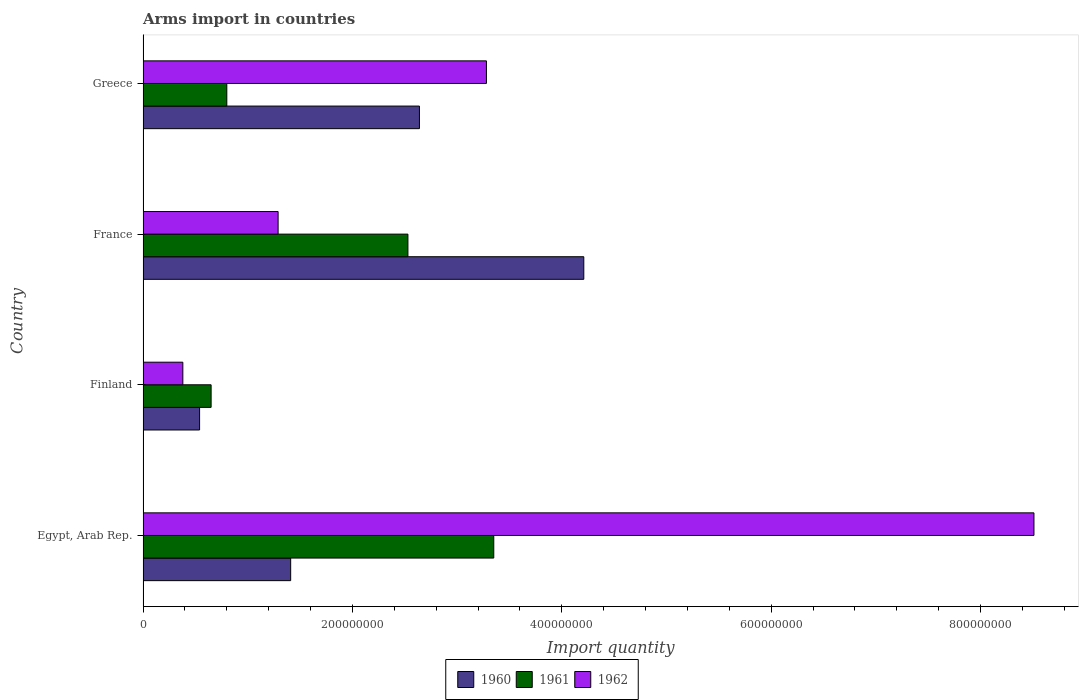How many different coloured bars are there?
Offer a very short reply. 3. How many groups of bars are there?
Provide a succinct answer. 4. Are the number of bars per tick equal to the number of legend labels?
Offer a very short reply. Yes. How many bars are there on the 2nd tick from the bottom?
Your answer should be very brief. 3. In how many cases, is the number of bars for a given country not equal to the number of legend labels?
Your answer should be very brief. 0. What is the total arms import in 1962 in Finland?
Your answer should be very brief. 3.80e+07. Across all countries, what is the maximum total arms import in 1961?
Offer a very short reply. 3.35e+08. Across all countries, what is the minimum total arms import in 1960?
Provide a succinct answer. 5.40e+07. In which country was the total arms import in 1960 maximum?
Provide a short and direct response. France. In which country was the total arms import in 1961 minimum?
Offer a very short reply. Finland. What is the total total arms import in 1962 in the graph?
Offer a terse response. 1.35e+09. What is the difference between the total arms import in 1961 in Egypt, Arab Rep. and that in France?
Keep it short and to the point. 8.20e+07. What is the difference between the total arms import in 1962 in Greece and the total arms import in 1961 in France?
Provide a succinct answer. 7.50e+07. What is the average total arms import in 1962 per country?
Provide a short and direct response. 3.36e+08. What is the difference between the total arms import in 1960 and total arms import in 1962 in Greece?
Offer a terse response. -6.40e+07. In how many countries, is the total arms import in 1962 greater than 520000000 ?
Give a very brief answer. 1. What is the ratio of the total arms import in 1962 in Egypt, Arab Rep. to that in Greece?
Your answer should be compact. 2.59. Is the total arms import in 1961 in Finland less than that in France?
Provide a succinct answer. Yes. Is the difference between the total arms import in 1960 in France and Greece greater than the difference between the total arms import in 1962 in France and Greece?
Ensure brevity in your answer.  Yes. What is the difference between the highest and the second highest total arms import in 1960?
Provide a short and direct response. 1.57e+08. What is the difference between the highest and the lowest total arms import in 1960?
Ensure brevity in your answer.  3.67e+08. What does the 2nd bar from the top in Greece represents?
Offer a terse response. 1961. Is it the case that in every country, the sum of the total arms import in 1962 and total arms import in 1960 is greater than the total arms import in 1961?
Your answer should be very brief. Yes. How many bars are there?
Your response must be concise. 12. Are all the bars in the graph horizontal?
Give a very brief answer. Yes. Does the graph contain any zero values?
Your answer should be very brief. No. Does the graph contain grids?
Make the answer very short. No. What is the title of the graph?
Your response must be concise. Arms import in countries. What is the label or title of the X-axis?
Make the answer very short. Import quantity. What is the label or title of the Y-axis?
Provide a short and direct response. Country. What is the Import quantity of 1960 in Egypt, Arab Rep.?
Provide a short and direct response. 1.41e+08. What is the Import quantity of 1961 in Egypt, Arab Rep.?
Provide a short and direct response. 3.35e+08. What is the Import quantity of 1962 in Egypt, Arab Rep.?
Your response must be concise. 8.51e+08. What is the Import quantity in 1960 in Finland?
Your response must be concise. 5.40e+07. What is the Import quantity in 1961 in Finland?
Offer a very short reply. 6.50e+07. What is the Import quantity of 1962 in Finland?
Keep it short and to the point. 3.80e+07. What is the Import quantity in 1960 in France?
Make the answer very short. 4.21e+08. What is the Import quantity of 1961 in France?
Give a very brief answer. 2.53e+08. What is the Import quantity of 1962 in France?
Provide a succinct answer. 1.29e+08. What is the Import quantity in 1960 in Greece?
Keep it short and to the point. 2.64e+08. What is the Import quantity of 1961 in Greece?
Make the answer very short. 8.00e+07. What is the Import quantity of 1962 in Greece?
Make the answer very short. 3.28e+08. Across all countries, what is the maximum Import quantity in 1960?
Provide a succinct answer. 4.21e+08. Across all countries, what is the maximum Import quantity of 1961?
Offer a terse response. 3.35e+08. Across all countries, what is the maximum Import quantity in 1962?
Make the answer very short. 8.51e+08. Across all countries, what is the minimum Import quantity in 1960?
Provide a succinct answer. 5.40e+07. Across all countries, what is the minimum Import quantity in 1961?
Keep it short and to the point. 6.50e+07. Across all countries, what is the minimum Import quantity in 1962?
Offer a terse response. 3.80e+07. What is the total Import quantity of 1960 in the graph?
Make the answer very short. 8.80e+08. What is the total Import quantity in 1961 in the graph?
Give a very brief answer. 7.33e+08. What is the total Import quantity in 1962 in the graph?
Offer a very short reply. 1.35e+09. What is the difference between the Import quantity of 1960 in Egypt, Arab Rep. and that in Finland?
Provide a short and direct response. 8.70e+07. What is the difference between the Import quantity in 1961 in Egypt, Arab Rep. and that in Finland?
Ensure brevity in your answer.  2.70e+08. What is the difference between the Import quantity of 1962 in Egypt, Arab Rep. and that in Finland?
Your answer should be compact. 8.13e+08. What is the difference between the Import quantity of 1960 in Egypt, Arab Rep. and that in France?
Your response must be concise. -2.80e+08. What is the difference between the Import quantity in 1961 in Egypt, Arab Rep. and that in France?
Ensure brevity in your answer.  8.20e+07. What is the difference between the Import quantity of 1962 in Egypt, Arab Rep. and that in France?
Your answer should be compact. 7.22e+08. What is the difference between the Import quantity in 1960 in Egypt, Arab Rep. and that in Greece?
Offer a terse response. -1.23e+08. What is the difference between the Import quantity of 1961 in Egypt, Arab Rep. and that in Greece?
Make the answer very short. 2.55e+08. What is the difference between the Import quantity of 1962 in Egypt, Arab Rep. and that in Greece?
Offer a terse response. 5.23e+08. What is the difference between the Import quantity of 1960 in Finland and that in France?
Make the answer very short. -3.67e+08. What is the difference between the Import quantity of 1961 in Finland and that in France?
Your response must be concise. -1.88e+08. What is the difference between the Import quantity in 1962 in Finland and that in France?
Your answer should be very brief. -9.10e+07. What is the difference between the Import quantity of 1960 in Finland and that in Greece?
Give a very brief answer. -2.10e+08. What is the difference between the Import quantity in 1961 in Finland and that in Greece?
Offer a terse response. -1.50e+07. What is the difference between the Import quantity of 1962 in Finland and that in Greece?
Keep it short and to the point. -2.90e+08. What is the difference between the Import quantity in 1960 in France and that in Greece?
Make the answer very short. 1.57e+08. What is the difference between the Import quantity in 1961 in France and that in Greece?
Give a very brief answer. 1.73e+08. What is the difference between the Import quantity in 1962 in France and that in Greece?
Offer a terse response. -1.99e+08. What is the difference between the Import quantity of 1960 in Egypt, Arab Rep. and the Import quantity of 1961 in Finland?
Give a very brief answer. 7.60e+07. What is the difference between the Import quantity of 1960 in Egypt, Arab Rep. and the Import quantity of 1962 in Finland?
Your response must be concise. 1.03e+08. What is the difference between the Import quantity of 1961 in Egypt, Arab Rep. and the Import quantity of 1962 in Finland?
Your answer should be very brief. 2.97e+08. What is the difference between the Import quantity in 1960 in Egypt, Arab Rep. and the Import quantity in 1961 in France?
Ensure brevity in your answer.  -1.12e+08. What is the difference between the Import quantity of 1961 in Egypt, Arab Rep. and the Import quantity of 1962 in France?
Your response must be concise. 2.06e+08. What is the difference between the Import quantity of 1960 in Egypt, Arab Rep. and the Import quantity of 1961 in Greece?
Ensure brevity in your answer.  6.10e+07. What is the difference between the Import quantity of 1960 in Egypt, Arab Rep. and the Import quantity of 1962 in Greece?
Offer a very short reply. -1.87e+08. What is the difference between the Import quantity of 1961 in Egypt, Arab Rep. and the Import quantity of 1962 in Greece?
Ensure brevity in your answer.  7.00e+06. What is the difference between the Import quantity of 1960 in Finland and the Import quantity of 1961 in France?
Your answer should be very brief. -1.99e+08. What is the difference between the Import quantity in 1960 in Finland and the Import quantity in 1962 in France?
Your answer should be compact. -7.50e+07. What is the difference between the Import quantity of 1961 in Finland and the Import quantity of 1962 in France?
Give a very brief answer. -6.40e+07. What is the difference between the Import quantity of 1960 in Finland and the Import quantity of 1961 in Greece?
Provide a short and direct response. -2.60e+07. What is the difference between the Import quantity in 1960 in Finland and the Import quantity in 1962 in Greece?
Your answer should be compact. -2.74e+08. What is the difference between the Import quantity of 1961 in Finland and the Import quantity of 1962 in Greece?
Your answer should be compact. -2.63e+08. What is the difference between the Import quantity of 1960 in France and the Import quantity of 1961 in Greece?
Keep it short and to the point. 3.41e+08. What is the difference between the Import quantity in 1960 in France and the Import quantity in 1962 in Greece?
Provide a succinct answer. 9.30e+07. What is the difference between the Import quantity in 1961 in France and the Import quantity in 1962 in Greece?
Provide a succinct answer. -7.50e+07. What is the average Import quantity in 1960 per country?
Keep it short and to the point. 2.20e+08. What is the average Import quantity of 1961 per country?
Give a very brief answer. 1.83e+08. What is the average Import quantity of 1962 per country?
Give a very brief answer. 3.36e+08. What is the difference between the Import quantity of 1960 and Import quantity of 1961 in Egypt, Arab Rep.?
Provide a succinct answer. -1.94e+08. What is the difference between the Import quantity in 1960 and Import quantity in 1962 in Egypt, Arab Rep.?
Provide a short and direct response. -7.10e+08. What is the difference between the Import quantity in 1961 and Import quantity in 1962 in Egypt, Arab Rep.?
Keep it short and to the point. -5.16e+08. What is the difference between the Import quantity of 1960 and Import quantity of 1961 in Finland?
Give a very brief answer. -1.10e+07. What is the difference between the Import quantity of 1960 and Import quantity of 1962 in Finland?
Keep it short and to the point. 1.60e+07. What is the difference between the Import quantity of 1961 and Import quantity of 1962 in Finland?
Make the answer very short. 2.70e+07. What is the difference between the Import quantity of 1960 and Import quantity of 1961 in France?
Provide a succinct answer. 1.68e+08. What is the difference between the Import quantity in 1960 and Import quantity in 1962 in France?
Offer a terse response. 2.92e+08. What is the difference between the Import quantity of 1961 and Import quantity of 1962 in France?
Provide a short and direct response. 1.24e+08. What is the difference between the Import quantity in 1960 and Import quantity in 1961 in Greece?
Your answer should be very brief. 1.84e+08. What is the difference between the Import quantity in 1960 and Import quantity in 1962 in Greece?
Keep it short and to the point. -6.40e+07. What is the difference between the Import quantity in 1961 and Import quantity in 1962 in Greece?
Ensure brevity in your answer.  -2.48e+08. What is the ratio of the Import quantity in 1960 in Egypt, Arab Rep. to that in Finland?
Offer a terse response. 2.61. What is the ratio of the Import quantity in 1961 in Egypt, Arab Rep. to that in Finland?
Make the answer very short. 5.15. What is the ratio of the Import quantity of 1962 in Egypt, Arab Rep. to that in Finland?
Your answer should be compact. 22.39. What is the ratio of the Import quantity of 1960 in Egypt, Arab Rep. to that in France?
Your response must be concise. 0.33. What is the ratio of the Import quantity of 1961 in Egypt, Arab Rep. to that in France?
Offer a very short reply. 1.32. What is the ratio of the Import quantity in 1962 in Egypt, Arab Rep. to that in France?
Your answer should be very brief. 6.6. What is the ratio of the Import quantity of 1960 in Egypt, Arab Rep. to that in Greece?
Your response must be concise. 0.53. What is the ratio of the Import quantity of 1961 in Egypt, Arab Rep. to that in Greece?
Make the answer very short. 4.19. What is the ratio of the Import quantity of 1962 in Egypt, Arab Rep. to that in Greece?
Give a very brief answer. 2.59. What is the ratio of the Import quantity in 1960 in Finland to that in France?
Your answer should be very brief. 0.13. What is the ratio of the Import quantity of 1961 in Finland to that in France?
Provide a short and direct response. 0.26. What is the ratio of the Import quantity in 1962 in Finland to that in France?
Make the answer very short. 0.29. What is the ratio of the Import quantity in 1960 in Finland to that in Greece?
Your answer should be very brief. 0.2. What is the ratio of the Import quantity of 1961 in Finland to that in Greece?
Your answer should be very brief. 0.81. What is the ratio of the Import quantity of 1962 in Finland to that in Greece?
Make the answer very short. 0.12. What is the ratio of the Import quantity of 1960 in France to that in Greece?
Keep it short and to the point. 1.59. What is the ratio of the Import quantity in 1961 in France to that in Greece?
Keep it short and to the point. 3.16. What is the ratio of the Import quantity in 1962 in France to that in Greece?
Provide a short and direct response. 0.39. What is the difference between the highest and the second highest Import quantity in 1960?
Make the answer very short. 1.57e+08. What is the difference between the highest and the second highest Import quantity of 1961?
Keep it short and to the point. 8.20e+07. What is the difference between the highest and the second highest Import quantity in 1962?
Offer a terse response. 5.23e+08. What is the difference between the highest and the lowest Import quantity in 1960?
Your answer should be very brief. 3.67e+08. What is the difference between the highest and the lowest Import quantity of 1961?
Your answer should be very brief. 2.70e+08. What is the difference between the highest and the lowest Import quantity in 1962?
Make the answer very short. 8.13e+08. 